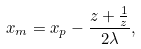<formula> <loc_0><loc_0><loc_500><loc_500>x _ { m } = x _ { p } - \frac { z + \frac { 1 } { z } } { 2 \lambda } ,</formula> 